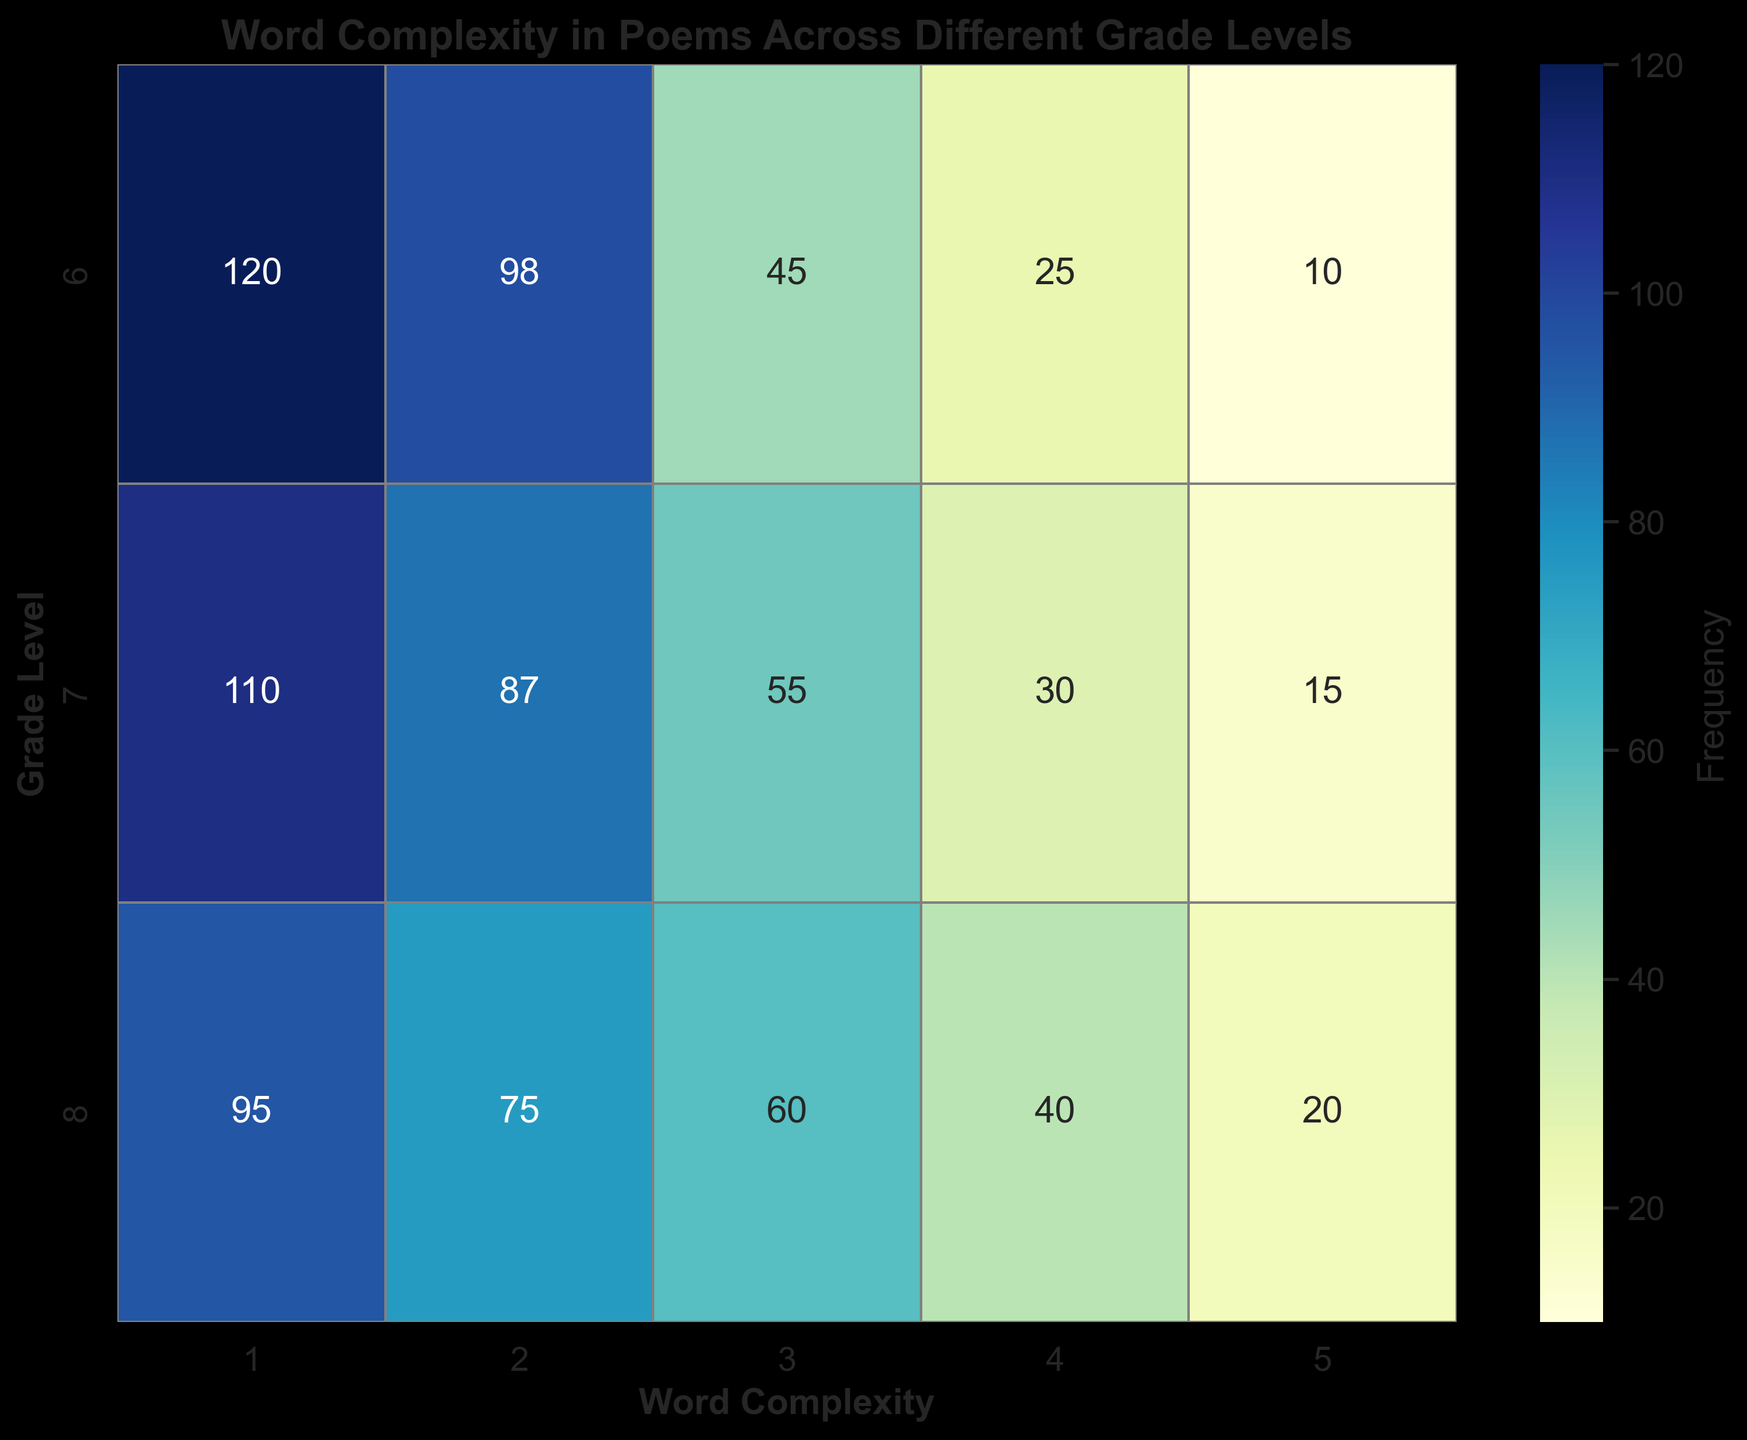What's the most common word complexity level in 6th-grade poems? The heatmap shows frequencies for each word complexity level in the 6th grade. Look at the row for Grade 6 and identify the highest frequency value. The highest value is 120 under Word Complexity 1.
Answer: 1 How does the frequency of Word Complexity 5 in 7th grade compare to 8th grade? Compare the values in the 5th Word Complexity column for both grades. The frequencies are 15 for 7th grade and 20 for 8th grade.
Answer: 8th grade is higher What is the average word complexity frequency for 7th grade poems? Add the frequencies for each word complexity level in the 7th grade and divide by the number of word complexity levels. The sum is 110 + 87 + 55 + 30 + 15 = 297. There are 5 levels, so 297 / 5 = 59.4.
Answer: 59.4 Which grade level has the most diverse range of word complexity frequencies? The grade with the widest spread between the highest and lowest frequencies indicates diversity. For 6th grade: 120 to 10, 7th grade: 110 to 15, and 8th grade: 95 to 20. Check max-min differences: 6th grade (110), 7th grade (95), 8th grade (75).
Answer: 6th grade What's the median frequency of the word complexity levels in 8th grade poems? Arrange the 8th-grade frequencies: 20, 40, 60, 75, 95. The middle value in this sorted list is the median.
Answer: 60 Are higher word complexity levels generally less frequent across all grades? Observe the patterns in all rows. As word complexity increases from 1 to 5, the frequencies generally decrease: highest frequencies at complexity 1 and lowest at complexity 5.
Answer: Yes Which word complexity level has the least frequency in 6th grade? Look at the values in the 6th-grade row and find the lowest frequency value. The lowest frequency is 10 at Word Complexity 5.
Answer: 5 How does the frequency of Word Complexity 3 in 6th grade compare to 7th grade? Check the 3rd Word Complexity column for both grades. The frequencies are 45 for 6th grade and 55 for 7th grade.
Answer: 7th grade is higher 